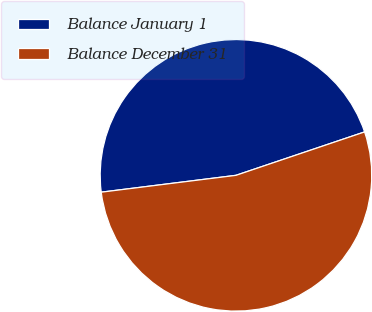Convert chart. <chart><loc_0><loc_0><loc_500><loc_500><pie_chart><fcel>Balance January 1<fcel>Balance December 31<nl><fcel>46.8%<fcel>53.2%<nl></chart> 